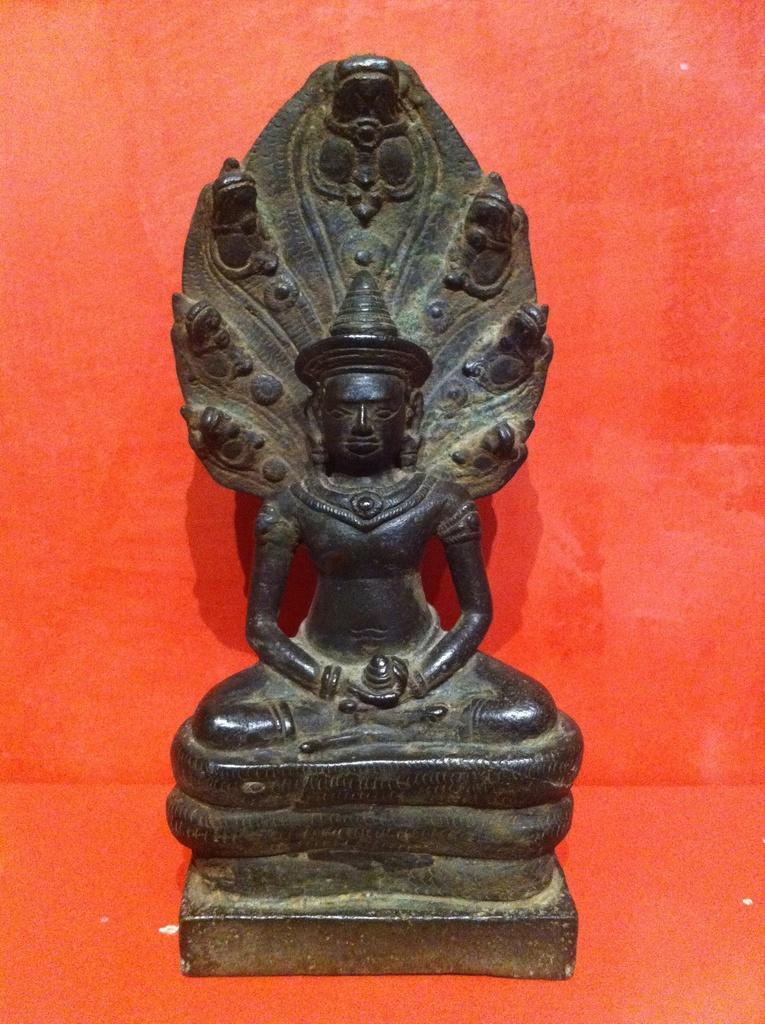How would you summarize this image in a sentence or two? As we can see in the image there is a wall and black color statue. 